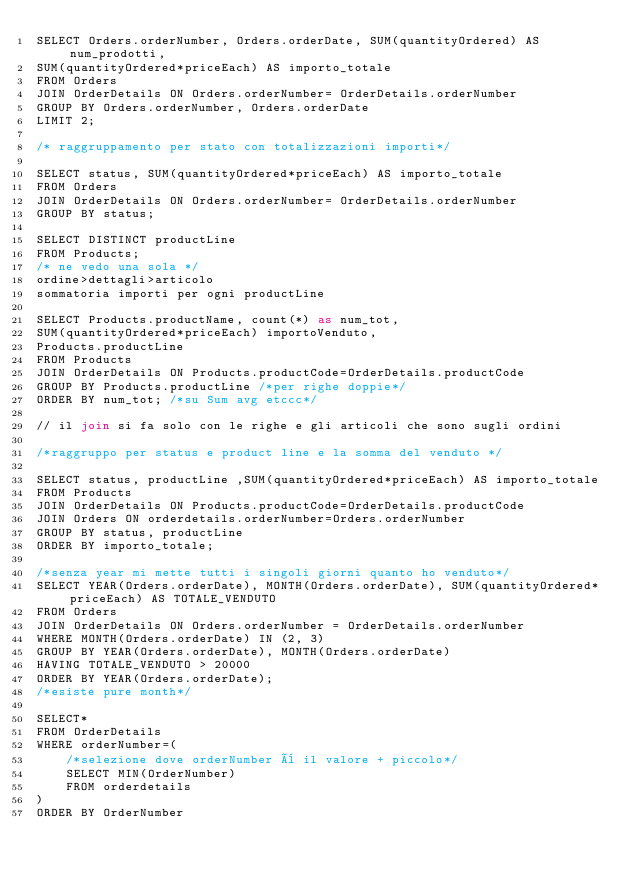<code> <loc_0><loc_0><loc_500><loc_500><_SQL_>SELECT Orders.orderNumber, Orders.orderDate, SUM(quantityOrdered) AS num_prodotti,
SUM(quantityOrdered*priceEach) AS importo_totale
FROM Orders 
JOIN OrderDetails ON Orders.orderNumber= OrderDetails.orderNumber
GROUP BY Orders.orderNumber, Orders.orderDate
LIMIT 2;

/* raggruppamento per stato con totalizzazioni importi*/

SELECT status, SUM(quantityOrdered*priceEach) AS importo_totale
FROM Orders 
JOIN OrderDetails ON Orders.orderNumber= OrderDetails.orderNumber
GROUP BY status;

SELECT DISTINCT productLine
FROM Products;
/* ne vedo una sola */
ordine>dettagli>articolo
sommatoria importi per ogni productLine

SELECT Products.productName, count(*) as num_tot,
SUM(quantityOrdered*priceEach) importoVenduto,
Products.productLine
FROM Products
JOIN OrderDetails ON Products.productCode=OrderDetails.productCode
GROUP BY Products.productLine /*per righe doppie*/
ORDER BY num_tot; /*su Sum avg etccc*/

// il join si fa solo con le righe e gli articoli che sono sugli ordini

/*raggruppo per status e product line e la somma del venduto */

SELECT status, productLine ,SUM(quantityOrdered*priceEach) AS importo_totale
FROM Products
JOIN OrderDetails ON Products.productCode=OrderDetails.productCode
JOIN Orders ON orderdetails.orderNumber=Orders.orderNumber
GROUP BY status, productLine 
ORDER BY importo_totale; 

/*senza year mi mette tutti i singoli giorni quanto ho venduto*/
SELECT YEAR(Orders.orderDate), MONTH(Orders.orderDate), SUM(quantityOrdered*priceEach) AS TOTALE_VENDUTO
FROM Orders
JOIN OrderDetails ON Orders.orderNumber = OrderDetails.orderNumber
WHERE MONTH(Orders.orderDate) IN (2, 3)
GROUP BY YEAR(Orders.orderDate), MONTH(Orders.orderDate)
HAVING TOTALE_VENDUTO > 20000
ORDER BY YEAR(Orders.orderDate);
/*esiste pure month*/

SELECT*
FROM OrderDetails
WHERE orderNumber=(
    /*selezione dove orderNumber è il valore + piccolo*/
    SELECT MIN(OrderNumber)
    FROM orderdetails
)
ORDER BY OrderNumber</code> 